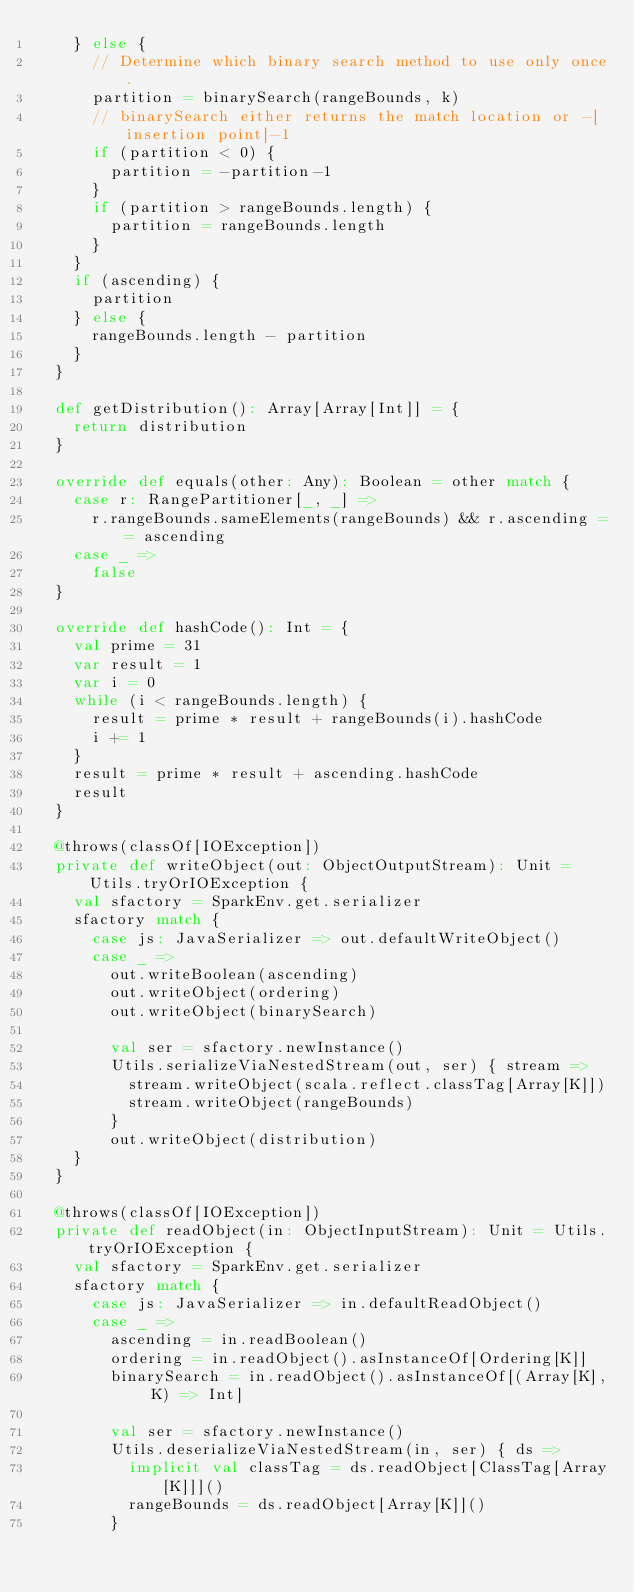<code> <loc_0><loc_0><loc_500><loc_500><_Scala_>    } else {
      // Determine which binary search method to use only once.
      partition = binarySearch(rangeBounds, k)
      // binarySearch either returns the match location or -[insertion point]-1
      if (partition < 0) {
        partition = -partition-1
      }
      if (partition > rangeBounds.length) {
        partition = rangeBounds.length
      }
    }
    if (ascending) {
      partition
    } else {
      rangeBounds.length - partition
    }
  }

  def getDistribution(): Array[Array[Int]] = {
    return distribution
  }

  override def equals(other: Any): Boolean = other match {
    case r: RangePartitioner[_, _] =>
      r.rangeBounds.sameElements(rangeBounds) && r.ascending == ascending
    case _ =>
      false
  }

  override def hashCode(): Int = {
    val prime = 31
    var result = 1
    var i = 0
    while (i < rangeBounds.length) {
      result = prime * result + rangeBounds(i).hashCode
      i += 1
    }
    result = prime * result + ascending.hashCode
    result
  }

  @throws(classOf[IOException])
  private def writeObject(out: ObjectOutputStream): Unit = Utils.tryOrIOException {
    val sfactory = SparkEnv.get.serializer
    sfactory match {
      case js: JavaSerializer => out.defaultWriteObject()
      case _ =>
        out.writeBoolean(ascending)
        out.writeObject(ordering)
        out.writeObject(binarySearch)

        val ser = sfactory.newInstance()
        Utils.serializeViaNestedStream(out, ser) { stream =>
          stream.writeObject(scala.reflect.classTag[Array[K]])
          stream.writeObject(rangeBounds)
        }
        out.writeObject(distribution)
    }
  }

  @throws(classOf[IOException])
  private def readObject(in: ObjectInputStream): Unit = Utils.tryOrIOException {
    val sfactory = SparkEnv.get.serializer
    sfactory match {
      case js: JavaSerializer => in.defaultReadObject()
      case _ =>
        ascending = in.readBoolean()
        ordering = in.readObject().asInstanceOf[Ordering[K]]
        binarySearch = in.readObject().asInstanceOf[(Array[K], K) => Int]

        val ser = sfactory.newInstance()
        Utils.deserializeViaNestedStream(in, ser) { ds =>
          implicit val classTag = ds.readObject[ClassTag[Array[K]]]()
          rangeBounds = ds.readObject[Array[K]]()
        }</code> 